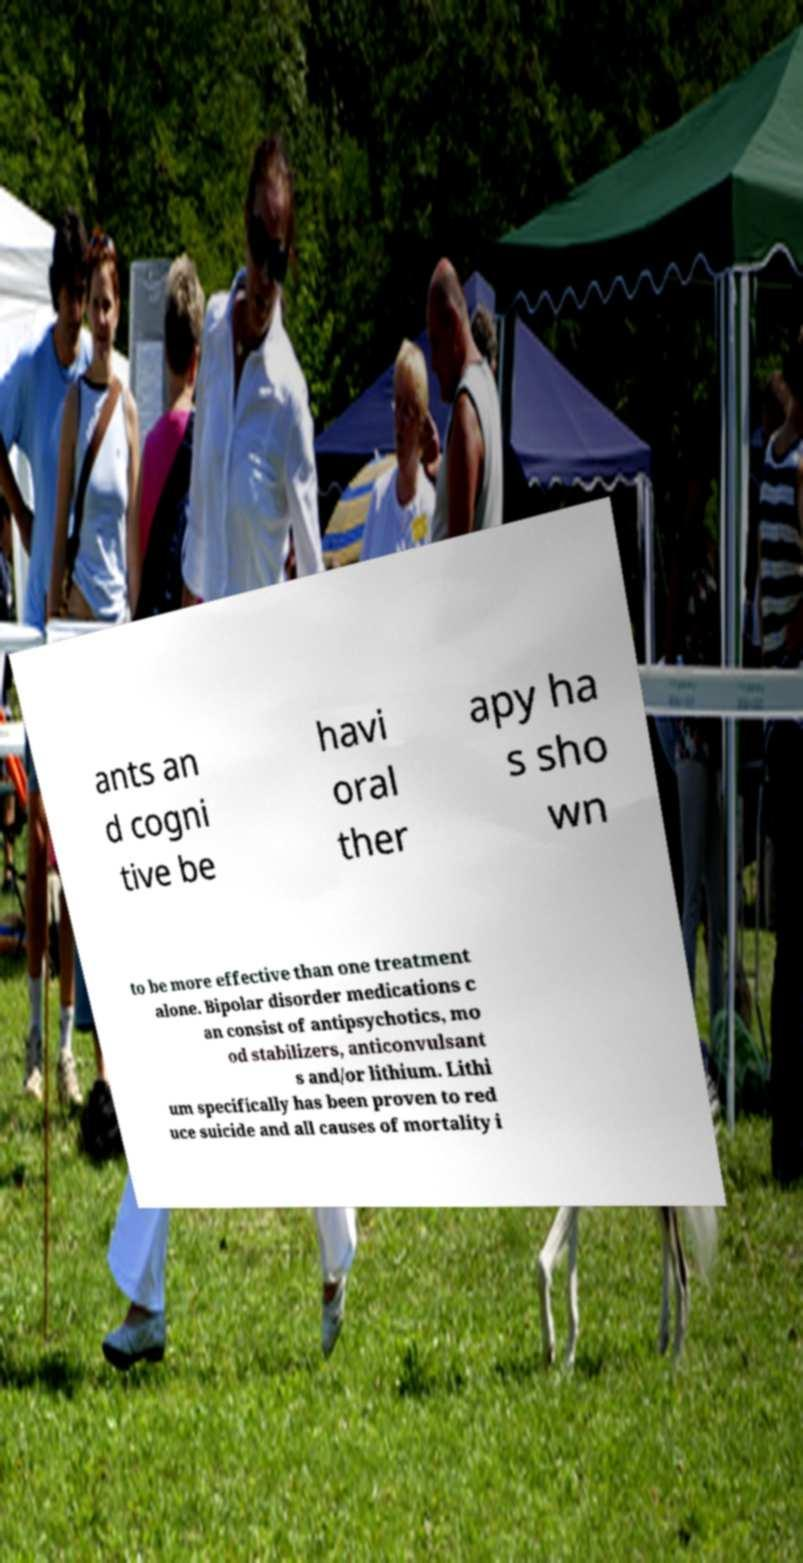Please read and relay the text visible in this image. What does it say? ants an d cogni tive be havi oral ther apy ha s sho wn to be more effective than one treatment alone. Bipolar disorder medications c an consist of antipsychotics, mo od stabilizers, anticonvulsant s and/or lithium. Lithi um specifically has been proven to red uce suicide and all causes of mortality i 